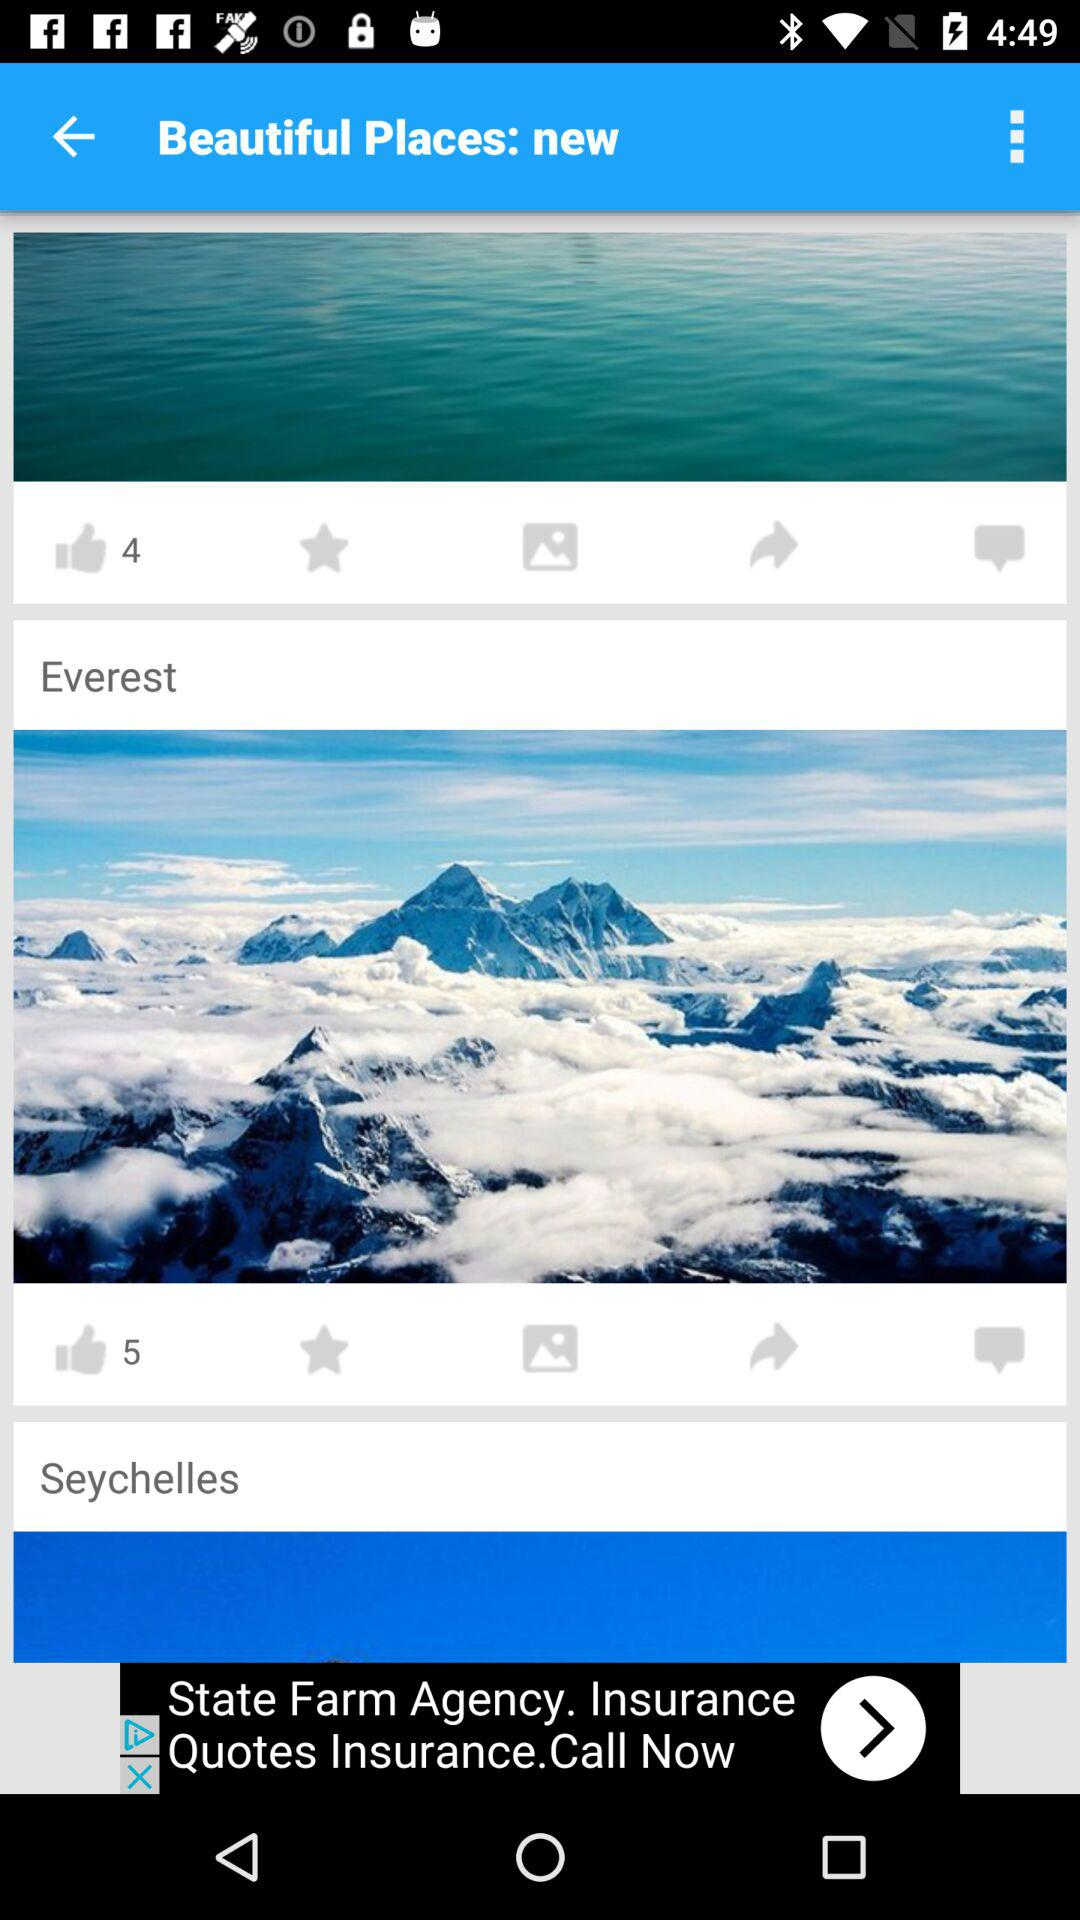How many people liked the image of Everest? The image of Everest is liked by five people. 